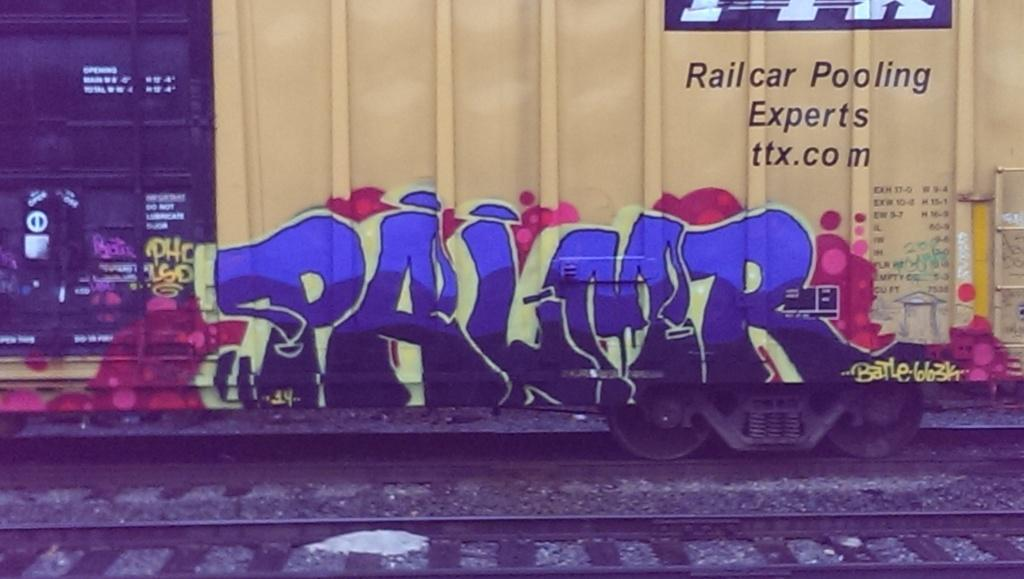<image>
Present a compact description of the photo's key features. A Palmer logo that looks like graffiti can be seen in front of railroad tracks. 